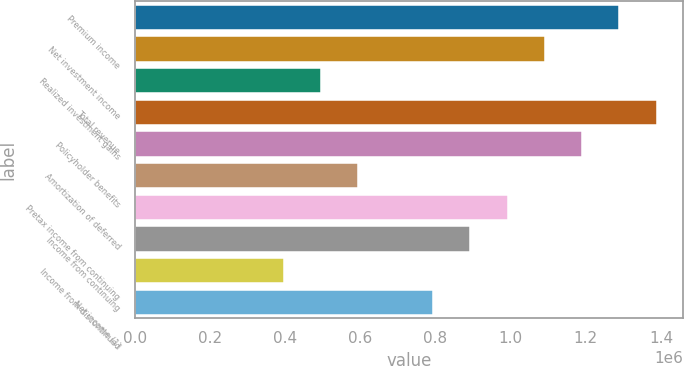<chart> <loc_0><loc_0><loc_500><loc_500><bar_chart><fcel>Premium income<fcel>Net investment income<fcel>Realized investment gains<fcel>Total revenue<fcel>Policyholder benefits<fcel>Amortization of deferred<fcel>Pretax income from continuing<fcel>Income from continuing<fcel>Income from discontinued<fcel>Net income (1)<nl><fcel>1.28945e+06<fcel>1.09107e+06<fcel>495942<fcel>1.38864e+06<fcel>1.19026e+06<fcel>595130<fcel>991884<fcel>892696<fcel>396754<fcel>793507<nl></chart> 